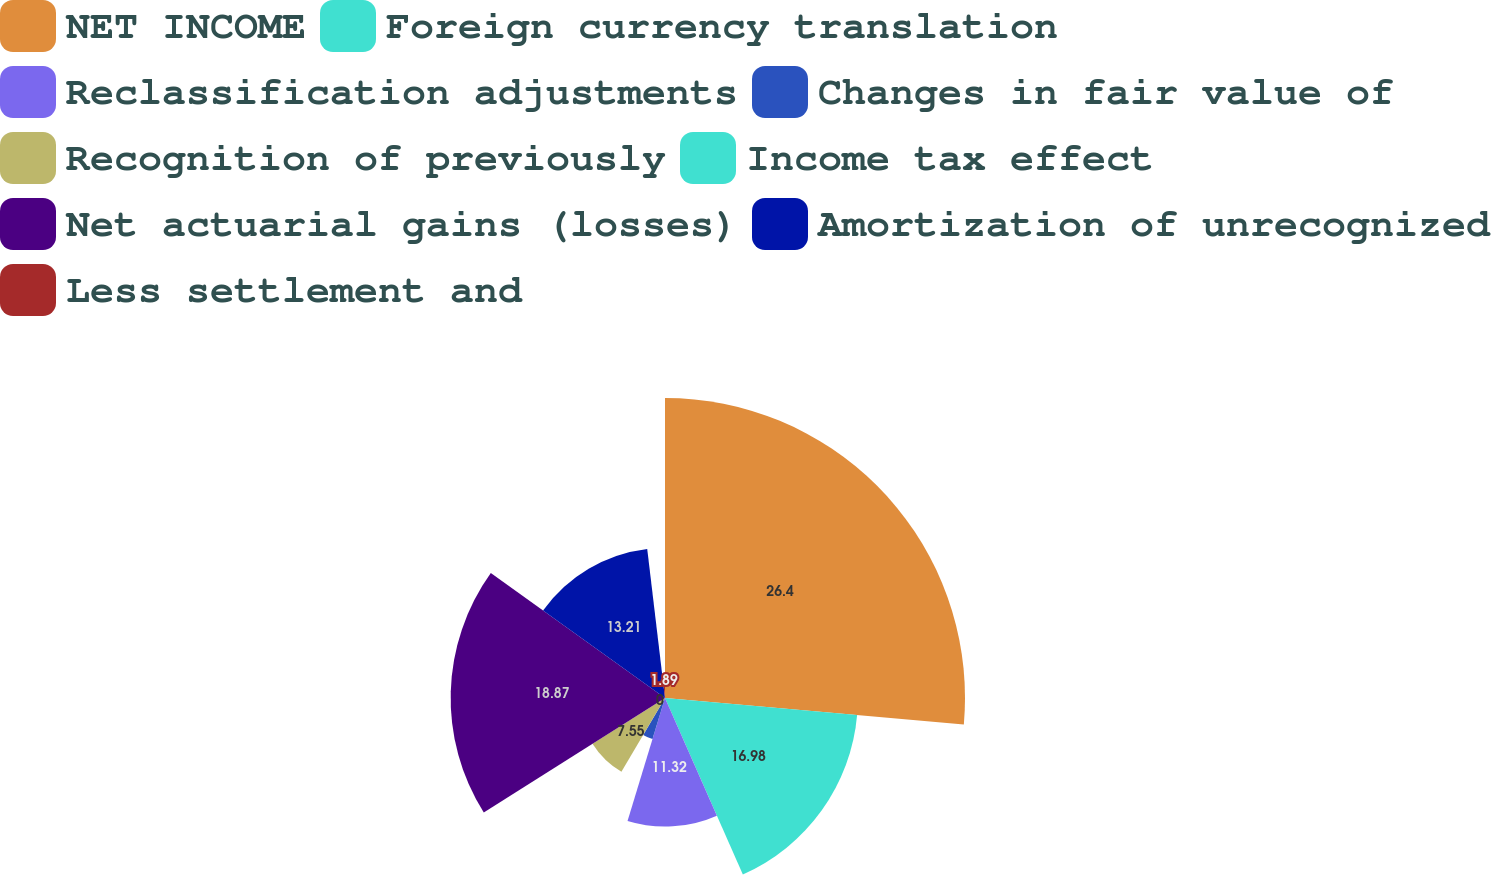<chart> <loc_0><loc_0><loc_500><loc_500><pie_chart><fcel>NET INCOME<fcel>Foreign currency translation<fcel>Reclassification adjustments<fcel>Changes in fair value of<fcel>Recognition of previously<fcel>Income tax effect<fcel>Net actuarial gains (losses)<fcel>Amortization of unrecognized<fcel>Less settlement and<nl><fcel>26.41%<fcel>16.98%<fcel>11.32%<fcel>3.78%<fcel>7.55%<fcel>0.0%<fcel>18.87%<fcel>13.21%<fcel>1.89%<nl></chart> 